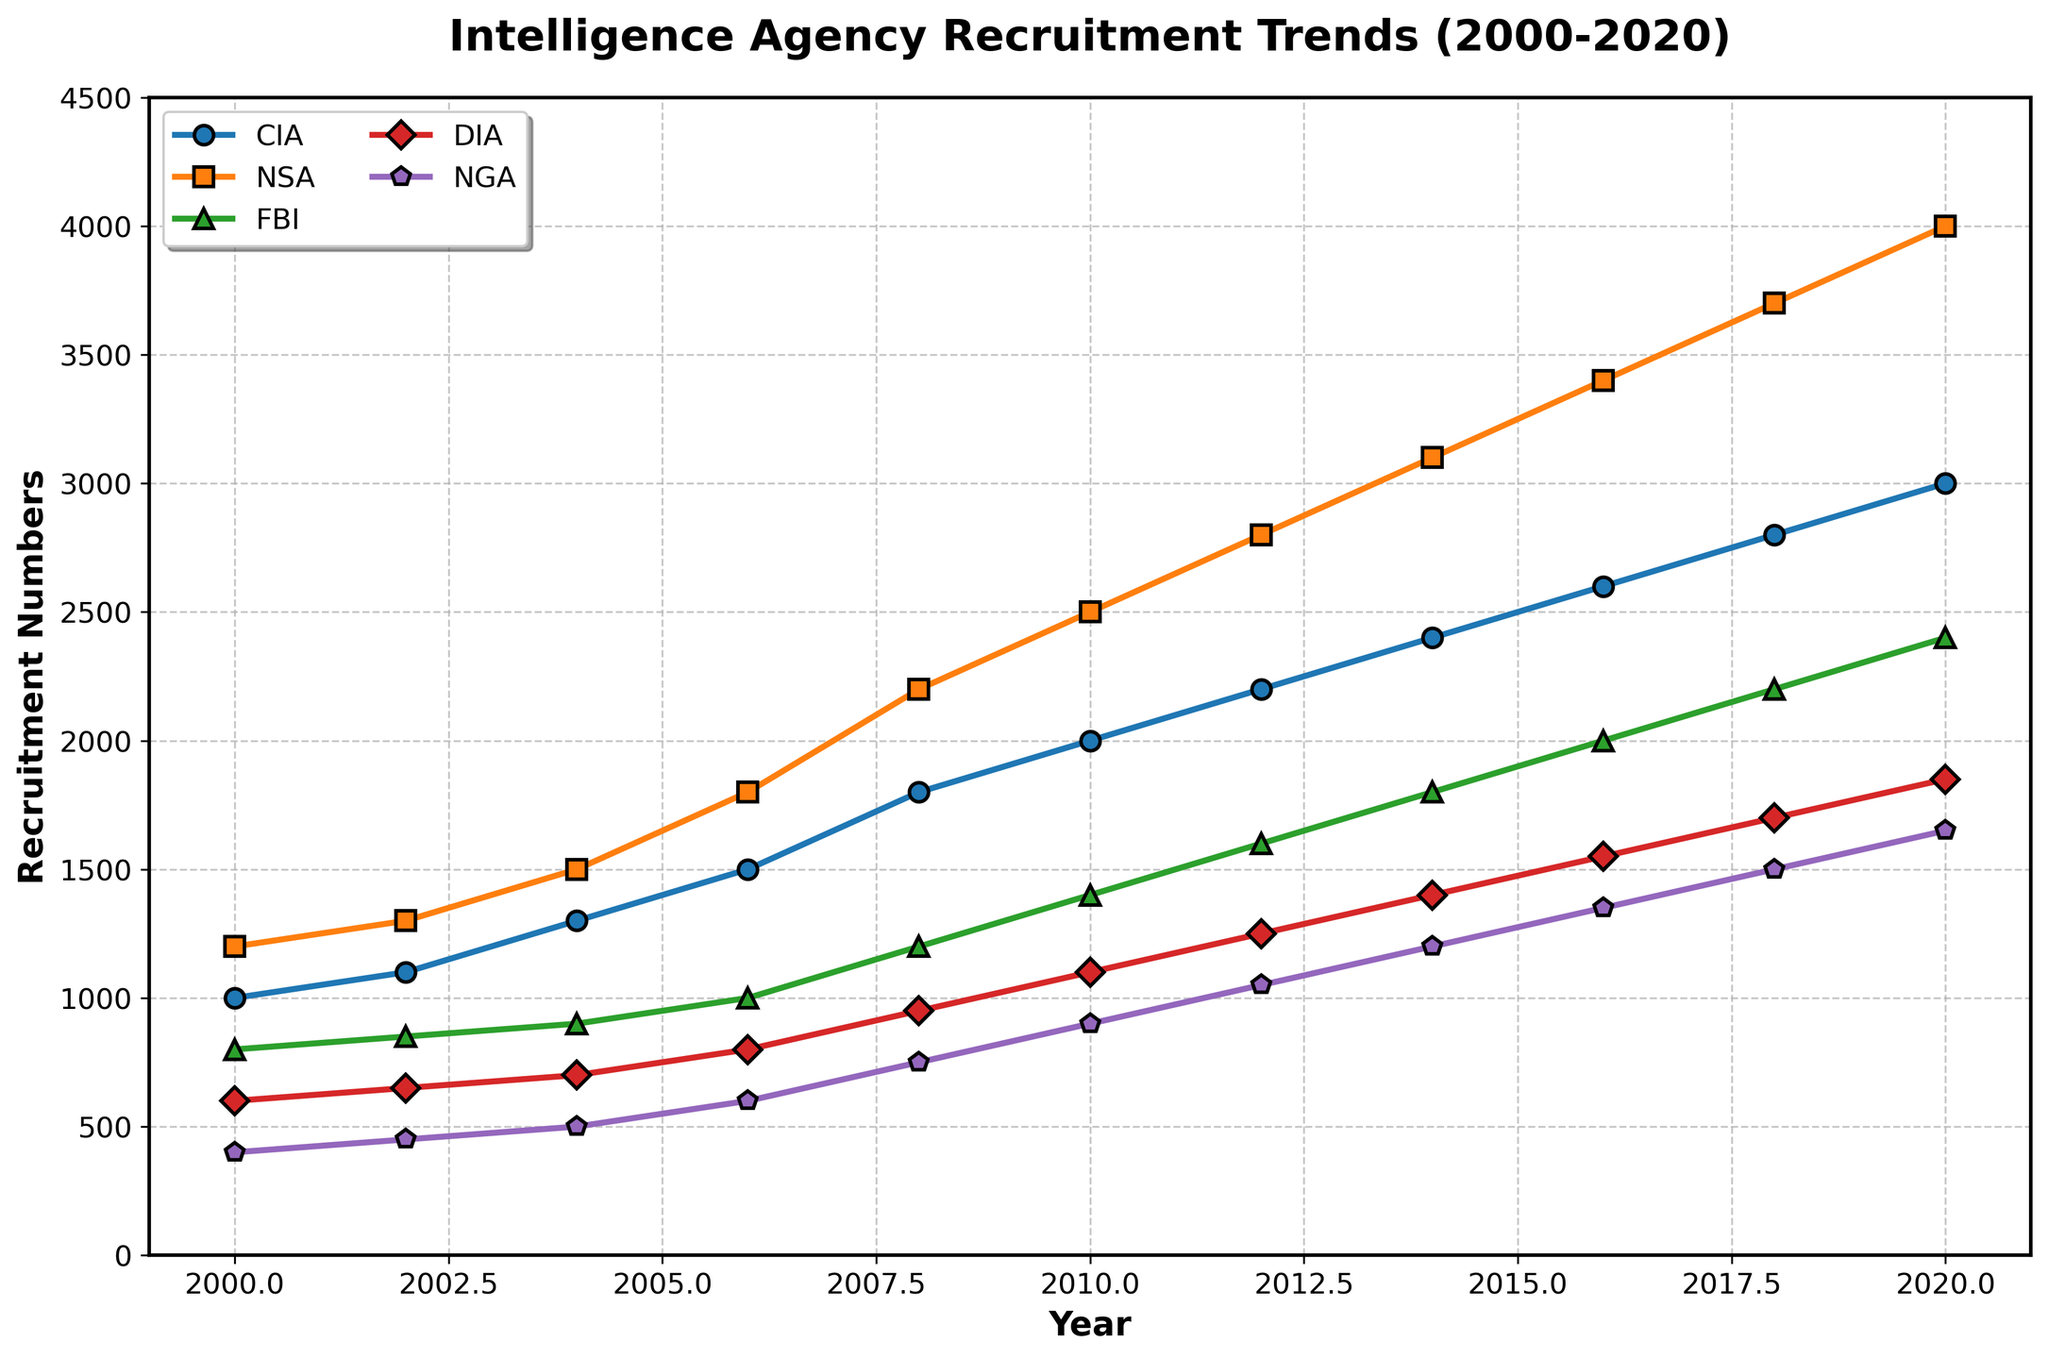What year did the NSA first surpass 2000 recruits? First, locate the NSA line in the chart. The NSA surpasses 2000 recruits between 2008 and 2010. By checking the specific point for 2010, it becomes clear that this is the first instance where it's above 2000.
Answer: 2010 Which agency saw the highest growth in recruitment numbers between 2000 and 2020? Calculate the increase for each agency from 2000 to 2020. The CIA increased by 2000 (3000-1000), NSA by 2800 (4000-1200), FBI by 1600 (2400-800), DIA by 1250 (1850-600), and NGA by 1250 (1650-400). The NSA saw the highest growth of 2800.
Answer: NSA What was the total recruitment across all agencies in 2004? Sum the recruitment numbers for each agency in 2004: 1300 (CIA) + 1500 (NSA) + 900 (FBI) + 700 (DIA) + 500 (NGA). The total is 4900.
Answer: 4900 In which year did the FBI reach 2000 recruits, and how many years later was this compared to the DIA reaching 1000 recruits? The FBI reached 2000 recruits in 2016. The DIA reached 1000 recruits in 2006. Therefore, it took the FBI 10 years longer to reach this milestone than the DIA.
Answer: 2016, 10 years How does the recruitment trend of the CIA compare visually to that of the NGA from 2000 to 2020? Visually inspect the lines for the CIA and the NGA. The CIA line is consistently above the NGA line and follows a more rapid increase, while the NGA shows a more gradual rise.
Answer: CIA faster increase What is the average recruitment number for the DIA over the observed years? Calculate the average recruitment number for the DIA: (600 + 650 + 700 + 800 + 950 + 1100 + 1250 + 1400 + 1550 + 1700 + 1850) / 11. The sum is 13550, and the average is 13550 / 11 ≈ 1232.
Answer: 1232 Between which consecutive years did the CIA witness the largest increase in recruitment? Compare the year-over-year increases for the CIA: 100 (2000-2002), 200 (2002-2004), 200 (2004-2006), 300 (2006-2008), 200 (2008-2010), 200 (2010-2012), 200 (2012-2014), 200 (2014-2016), 200 (2016-2018), 200 (2018-2020). The largest increase is between 2006-2008 (300).
Answer: 2006-2008 What color represents the NGA, and what is its significance? Identify the color used for the NGA line in the chart. The NGA is represented by purple. This consistent use of purple helps differentiate it from the other agencies visually.
Answer: Purple Which agency had the least number of recruits in 2006? Check the recruitment numbers for each agency in 2006. The numbers are: CIA (1500), NSA (1800), FBI (1000), DIA (800), NGA (600). The NGA had the least number of recruits.
Answer: NGA What are the combined recruitment numbers for NSA and CIA in 2012? Sum the numbers for NSA and CIA in 2012: 2800 (NSA) + 2200 (CIA). The combined number is 5000.
Answer: 5000 